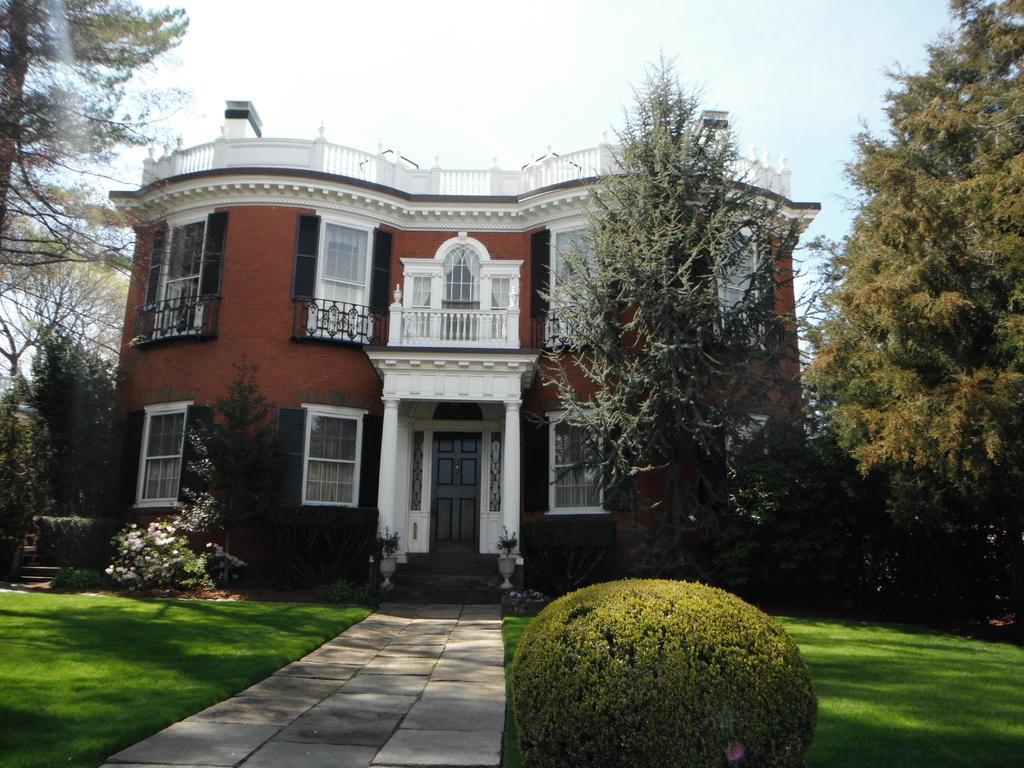Please provide a concise description of this image. In this image I can see a path in the centre and on the both sides of it I can see grass ground. I can also see a plant in the front. In the background I can see number of trees, a building, few more plants and the sky. I can also see number of windows and a door. 